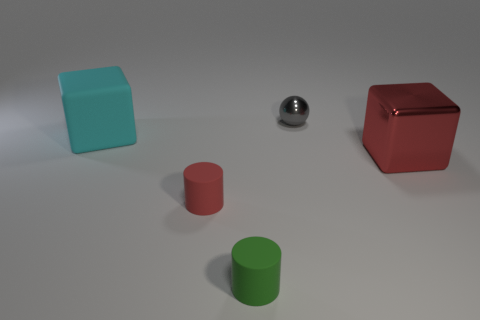Add 4 purple cylinders. How many objects exist? 9 Subtract all balls. How many objects are left? 4 Subtract 0 brown cylinders. How many objects are left? 5 Subtract all small matte cylinders. Subtract all small gray things. How many objects are left? 2 Add 3 small metal things. How many small metal things are left? 4 Add 3 gray shiny cylinders. How many gray shiny cylinders exist? 3 